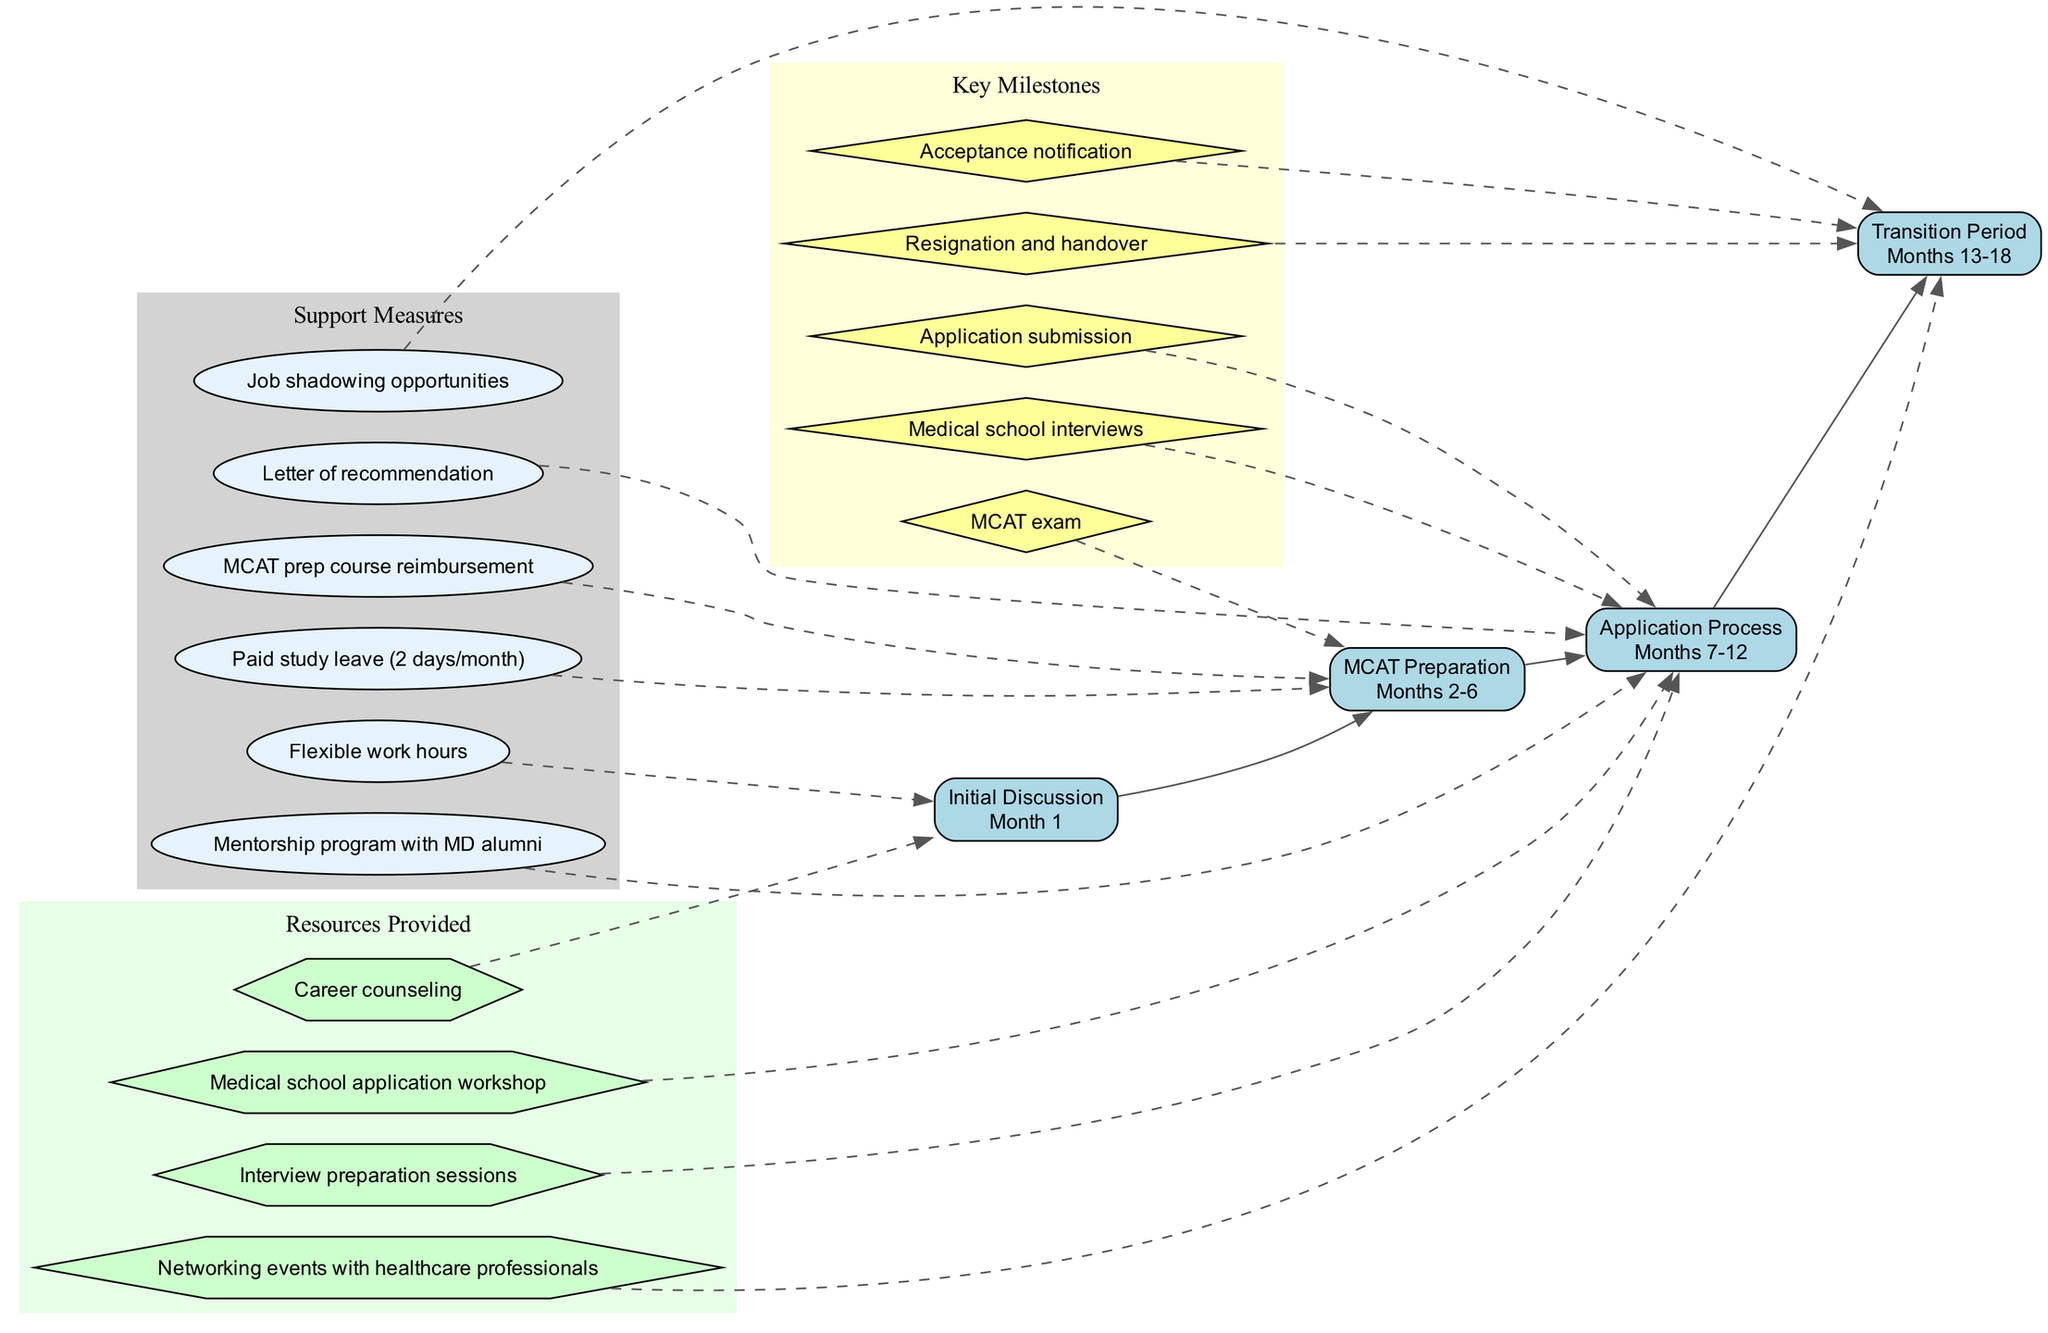What is the duration of the MCAT Preparation phase? The MCAT Preparation phase is specified in the timeline, which indicates it lasts from Months 2 to 6. This is a direct reference from the timeline provided.
Answer: Months 2-6 How many key milestones are listed in the diagram? The number of key milestones is found by counting the entries in the key milestones section. There are five distinct milestones mentioned.
Answer: 5 What support measure is associated with the Application Process phase? Examining the connections, the Application Process phase is connected to the Letter of recommendation and the Mentorship program with MD alumni, as indicated by the dashed lines from the support measures to the appropriate phase.
Answer: Letter of recommendation, Mentorship program with MD alumni Which phase comes after the Application Process? Following the Application Process phase in the sequence outlined in the timeline, the next phase is the Transition Period. This is based on the order of phases in the timeline.
Answer: Transition Period Are there any resources provided during the Initial Discussion phase? By looking at the connections from the resources provided section, we see that Career counseling is connected to the Initial Discussion phase. Therefore, one resource is provided during this phase.
Answer: Career counseling What phase has the acceptance notification as a key milestone? The Acceptance notification is associated with the Transition Period phase, as indicated by the dashed connection from this milestone to the corresponding phase in the timeline flow.
Answer: Transition Period What type of support is available during the MCAT Preparation phase? The support measures related to the MCAT Preparation phase include Flexible work hours and MCAT prep course reimbursement, which are both connected by dashed lines pointing to this phase.
Answer: Flexible work hours, MCAT prep course reimbursement In which months does the Transition Period take place? The timeline indicates that the Transition Period occurs between Months 13 and 18, which is explicitly stated in the timeline data provided.
Answer: Months 13-18 Which resource is available for medical school interview preparation? The Interview preparation sessions listed in the resources provided section indicate support specifically targeted toward preparing for medical school interviews, which corresponds to the needs during the Application Process phase.
Answer: Interview preparation sessions 